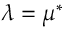<formula> <loc_0><loc_0><loc_500><loc_500>\lambda = \mu ^ { * }</formula> 